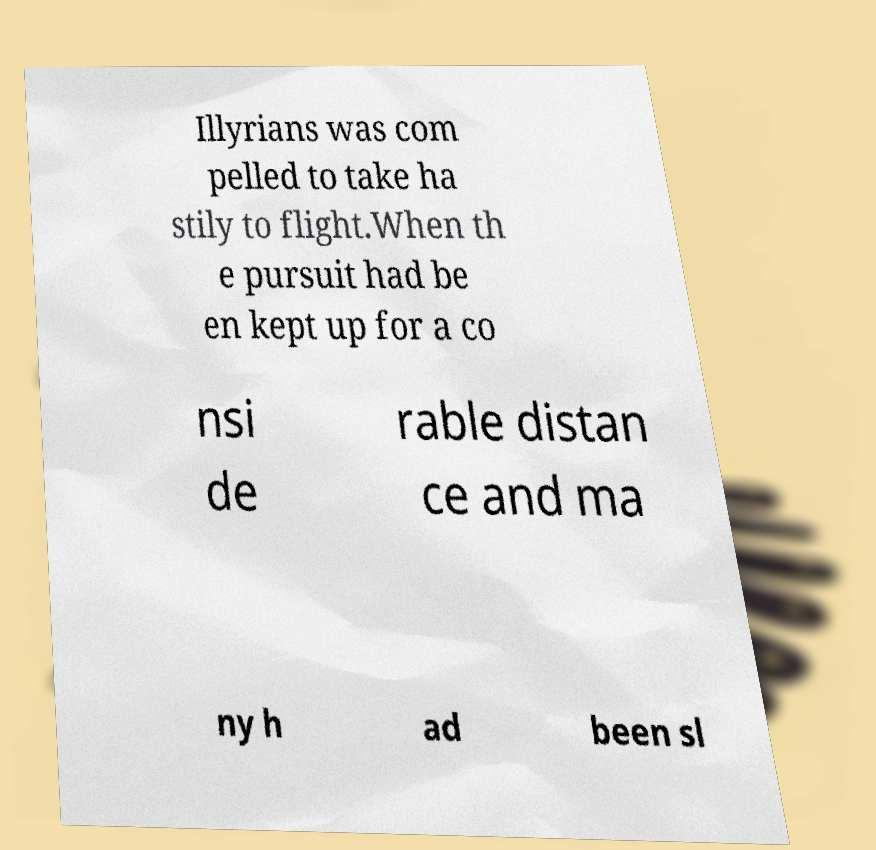What messages or text are displayed in this image? I need them in a readable, typed format. Illyrians was com pelled to take ha stily to flight.When th e pursuit had be en kept up for a co nsi de rable distan ce and ma ny h ad been sl 